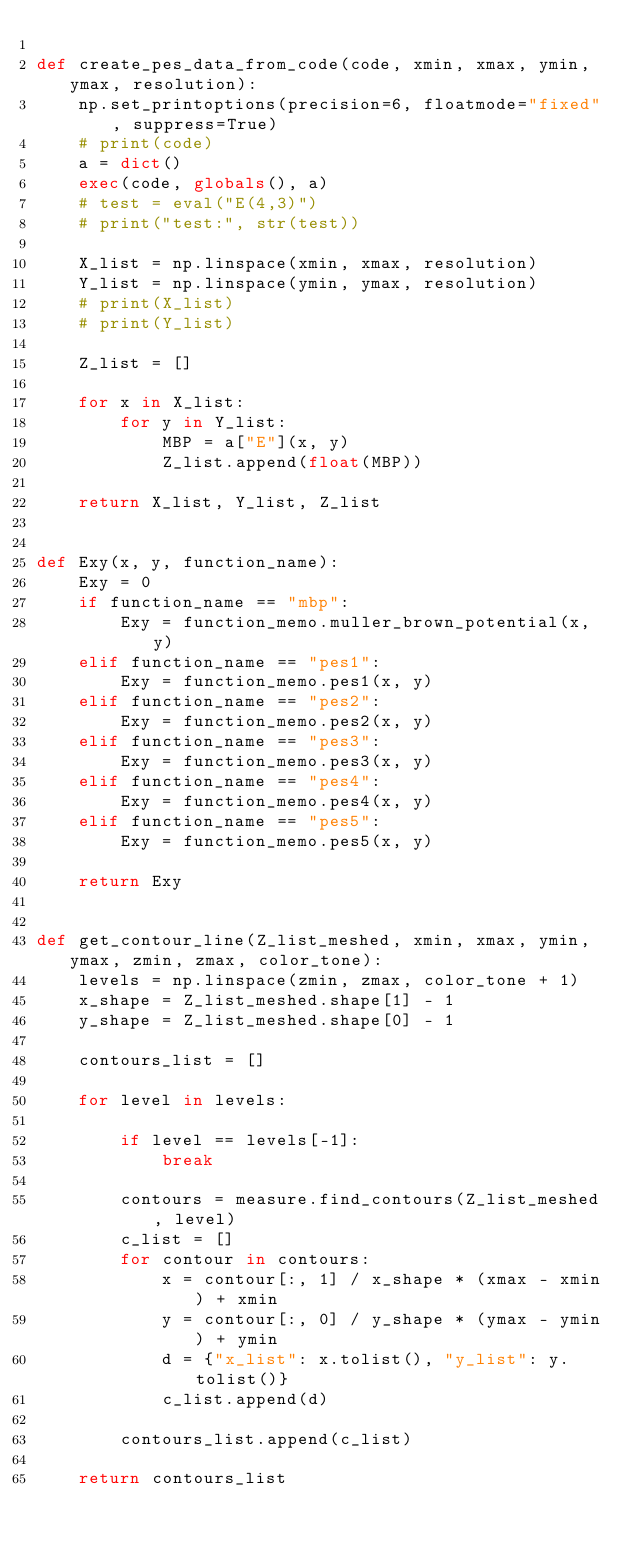Convert code to text. <code><loc_0><loc_0><loc_500><loc_500><_Python_>
def create_pes_data_from_code(code, xmin, xmax, ymin, ymax, resolution):
    np.set_printoptions(precision=6, floatmode="fixed", suppress=True)
    # print(code)
    a = dict()
    exec(code, globals(), a)
    # test = eval("E(4,3)")
    # print("test:", str(test))

    X_list = np.linspace(xmin, xmax, resolution)
    Y_list = np.linspace(ymin, ymax, resolution)
    # print(X_list)
    # print(Y_list)

    Z_list = []

    for x in X_list:
        for y in Y_list:
            MBP = a["E"](x, y)
            Z_list.append(float(MBP))

    return X_list, Y_list, Z_list


def Exy(x, y, function_name):
    Exy = 0
    if function_name == "mbp":
        Exy = function_memo.muller_brown_potential(x, y)
    elif function_name == "pes1":
        Exy = function_memo.pes1(x, y)
    elif function_name == "pes2":
        Exy = function_memo.pes2(x, y)
    elif function_name == "pes3":
        Exy = function_memo.pes3(x, y)
    elif function_name == "pes4":
        Exy = function_memo.pes4(x, y)
    elif function_name == "pes5":
        Exy = function_memo.pes5(x, y)

    return Exy


def get_contour_line(Z_list_meshed, xmin, xmax, ymin, ymax, zmin, zmax, color_tone):
    levels = np.linspace(zmin, zmax, color_tone + 1)
    x_shape = Z_list_meshed.shape[1] - 1
    y_shape = Z_list_meshed.shape[0] - 1

    contours_list = []

    for level in levels:

        if level == levels[-1]:
            break

        contours = measure.find_contours(Z_list_meshed, level)
        c_list = []
        for contour in contours:
            x = contour[:, 1] / x_shape * (xmax - xmin) + xmin
            y = contour[:, 0] / y_shape * (ymax - ymin) + ymin
            d = {"x_list": x.tolist(), "y_list": y.tolist()}
            c_list.append(d)

        contours_list.append(c_list)

    return contours_list
</code> 